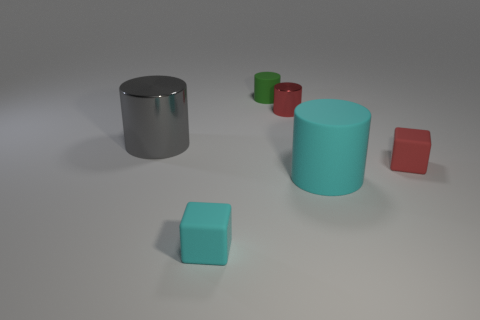How many rubber objects are the same color as the tiny metallic thing?
Give a very brief answer. 1. How many other things are there of the same material as the cyan cube?
Provide a succinct answer. 3. What is the material of the red thing that is in front of the big object that is behind the rubber block to the right of the red metal cylinder?
Offer a terse response. Rubber. Are the big gray cylinder and the small green object made of the same material?
Offer a terse response. No. What number of cubes are cyan rubber things or green matte things?
Your answer should be compact. 1. There is a small matte block in front of the big rubber object; what color is it?
Make the answer very short. Cyan. What number of shiny things are either gray things or red cylinders?
Give a very brief answer. 2. What material is the small red thing to the right of the shiny cylinder that is behind the gray thing?
Ensure brevity in your answer.  Rubber. There is a small block that is the same color as the large matte cylinder; what is it made of?
Offer a very short reply. Rubber. What is the color of the big matte object?
Provide a succinct answer. Cyan. 